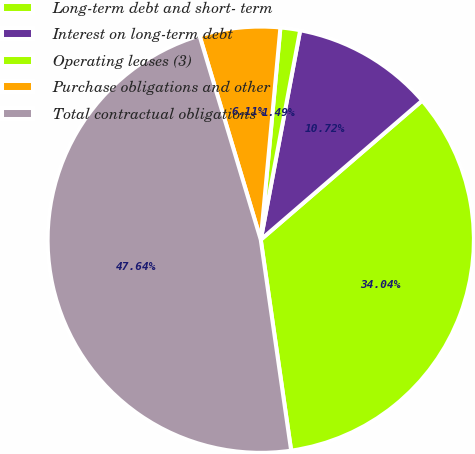<chart> <loc_0><loc_0><loc_500><loc_500><pie_chart><fcel>Long-term debt and short- term<fcel>Interest on long-term debt<fcel>Operating leases (3)<fcel>Purchase obligations and other<fcel>Total contractual obligations<nl><fcel>34.04%<fcel>10.72%<fcel>1.49%<fcel>6.11%<fcel>47.64%<nl></chart> 